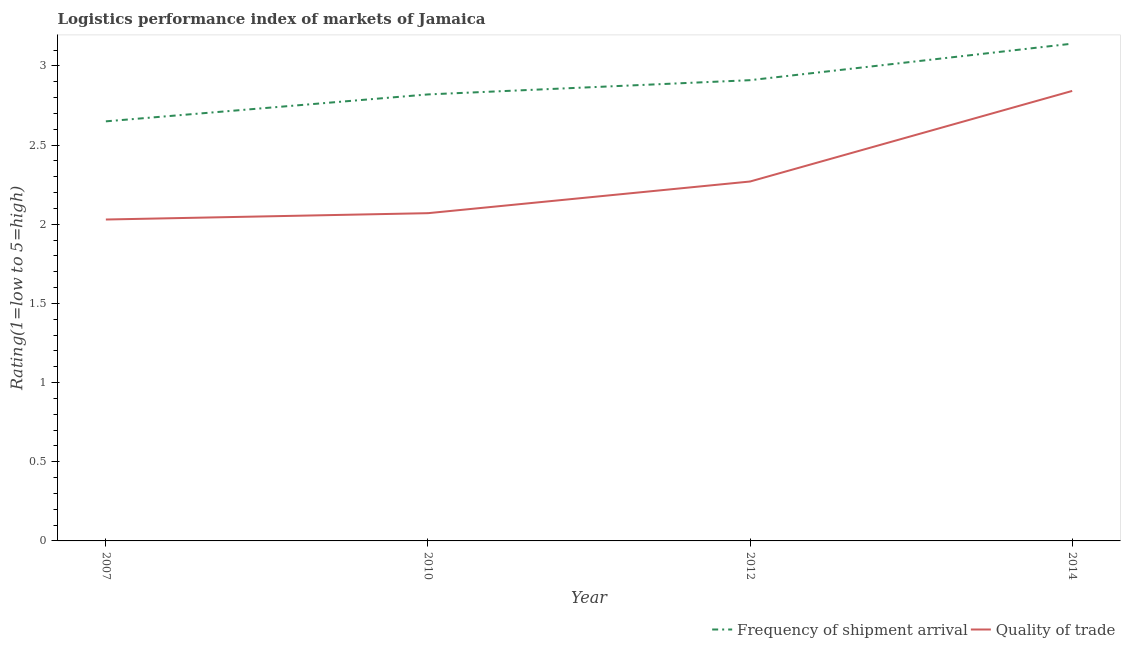What is the lpi of frequency of shipment arrival in 2014?
Make the answer very short. 3.14. Across all years, what is the maximum lpi of frequency of shipment arrival?
Your response must be concise. 3.14. Across all years, what is the minimum lpi of frequency of shipment arrival?
Your answer should be very brief. 2.65. In which year was the lpi quality of trade minimum?
Provide a succinct answer. 2007. What is the total lpi quality of trade in the graph?
Offer a very short reply. 9.21. What is the difference between the lpi of frequency of shipment arrival in 2010 and that in 2012?
Give a very brief answer. -0.09. What is the difference between the lpi quality of trade in 2007 and the lpi of frequency of shipment arrival in 2014?
Provide a short and direct response. -1.11. What is the average lpi of frequency of shipment arrival per year?
Offer a terse response. 2.88. In the year 2007, what is the difference between the lpi of frequency of shipment arrival and lpi quality of trade?
Offer a very short reply. 0.62. In how many years, is the lpi of frequency of shipment arrival greater than 0.30000000000000004?
Offer a very short reply. 4. What is the ratio of the lpi of frequency of shipment arrival in 2012 to that in 2014?
Provide a short and direct response. 0.93. What is the difference between the highest and the second highest lpi quality of trade?
Provide a succinct answer. 0.57. What is the difference between the highest and the lowest lpi quality of trade?
Give a very brief answer. 0.81. Is the sum of the lpi quality of trade in 2010 and 2012 greater than the maximum lpi of frequency of shipment arrival across all years?
Ensure brevity in your answer.  Yes. Does the lpi of frequency of shipment arrival monotonically increase over the years?
Give a very brief answer. Yes. Is the lpi quality of trade strictly greater than the lpi of frequency of shipment arrival over the years?
Your answer should be compact. No. Is the lpi of frequency of shipment arrival strictly less than the lpi quality of trade over the years?
Provide a succinct answer. No. How many years are there in the graph?
Keep it short and to the point. 4. What is the difference between two consecutive major ticks on the Y-axis?
Ensure brevity in your answer.  0.5. Does the graph contain any zero values?
Your answer should be compact. No. Does the graph contain grids?
Your answer should be very brief. No. What is the title of the graph?
Provide a succinct answer. Logistics performance index of markets of Jamaica. What is the label or title of the Y-axis?
Offer a very short reply. Rating(1=low to 5=high). What is the Rating(1=low to 5=high) in Frequency of shipment arrival in 2007?
Give a very brief answer. 2.65. What is the Rating(1=low to 5=high) of Quality of trade in 2007?
Ensure brevity in your answer.  2.03. What is the Rating(1=low to 5=high) of Frequency of shipment arrival in 2010?
Your response must be concise. 2.82. What is the Rating(1=low to 5=high) in Quality of trade in 2010?
Your answer should be compact. 2.07. What is the Rating(1=low to 5=high) of Frequency of shipment arrival in 2012?
Your answer should be very brief. 2.91. What is the Rating(1=low to 5=high) in Quality of trade in 2012?
Give a very brief answer. 2.27. What is the Rating(1=low to 5=high) in Frequency of shipment arrival in 2014?
Offer a terse response. 3.14. What is the Rating(1=low to 5=high) in Quality of trade in 2014?
Offer a very short reply. 2.84. Across all years, what is the maximum Rating(1=low to 5=high) of Frequency of shipment arrival?
Provide a short and direct response. 3.14. Across all years, what is the maximum Rating(1=low to 5=high) of Quality of trade?
Provide a succinct answer. 2.84. Across all years, what is the minimum Rating(1=low to 5=high) in Frequency of shipment arrival?
Offer a terse response. 2.65. Across all years, what is the minimum Rating(1=low to 5=high) of Quality of trade?
Provide a succinct answer. 2.03. What is the total Rating(1=low to 5=high) in Frequency of shipment arrival in the graph?
Ensure brevity in your answer.  11.52. What is the total Rating(1=low to 5=high) of Quality of trade in the graph?
Make the answer very short. 9.21. What is the difference between the Rating(1=low to 5=high) in Frequency of shipment arrival in 2007 and that in 2010?
Ensure brevity in your answer.  -0.17. What is the difference between the Rating(1=low to 5=high) in Quality of trade in 2007 and that in 2010?
Ensure brevity in your answer.  -0.04. What is the difference between the Rating(1=low to 5=high) in Frequency of shipment arrival in 2007 and that in 2012?
Ensure brevity in your answer.  -0.26. What is the difference between the Rating(1=low to 5=high) of Quality of trade in 2007 and that in 2012?
Keep it short and to the point. -0.24. What is the difference between the Rating(1=low to 5=high) of Frequency of shipment arrival in 2007 and that in 2014?
Your answer should be very brief. -0.49. What is the difference between the Rating(1=low to 5=high) in Quality of trade in 2007 and that in 2014?
Your answer should be very brief. -0.81. What is the difference between the Rating(1=low to 5=high) of Frequency of shipment arrival in 2010 and that in 2012?
Provide a short and direct response. -0.09. What is the difference between the Rating(1=low to 5=high) in Frequency of shipment arrival in 2010 and that in 2014?
Give a very brief answer. -0.32. What is the difference between the Rating(1=low to 5=high) in Quality of trade in 2010 and that in 2014?
Your response must be concise. -0.77. What is the difference between the Rating(1=low to 5=high) of Frequency of shipment arrival in 2012 and that in 2014?
Provide a succinct answer. -0.23. What is the difference between the Rating(1=low to 5=high) of Quality of trade in 2012 and that in 2014?
Offer a terse response. -0.57. What is the difference between the Rating(1=low to 5=high) in Frequency of shipment arrival in 2007 and the Rating(1=low to 5=high) in Quality of trade in 2010?
Ensure brevity in your answer.  0.58. What is the difference between the Rating(1=low to 5=high) of Frequency of shipment arrival in 2007 and the Rating(1=low to 5=high) of Quality of trade in 2012?
Offer a very short reply. 0.38. What is the difference between the Rating(1=low to 5=high) of Frequency of shipment arrival in 2007 and the Rating(1=low to 5=high) of Quality of trade in 2014?
Keep it short and to the point. -0.19. What is the difference between the Rating(1=low to 5=high) of Frequency of shipment arrival in 2010 and the Rating(1=low to 5=high) of Quality of trade in 2012?
Your response must be concise. 0.55. What is the difference between the Rating(1=low to 5=high) in Frequency of shipment arrival in 2010 and the Rating(1=low to 5=high) in Quality of trade in 2014?
Your answer should be compact. -0.02. What is the difference between the Rating(1=low to 5=high) in Frequency of shipment arrival in 2012 and the Rating(1=low to 5=high) in Quality of trade in 2014?
Your answer should be very brief. 0.07. What is the average Rating(1=low to 5=high) of Frequency of shipment arrival per year?
Offer a very short reply. 2.88. What is the average Rating(1=low to 5=high) in Quality of trade per year?
Offer a very short reply. 2.3. In the year 2007, what is the difference between the Rating(1=low to 5=high) in Frequency of shipment arrival and Rating(1=low to 5=high) in Quality of trade?
Give a very brief answer. 0.62. In the year 2010, what is the difference between the Rating(1=low to 5=high) in Frequency of shipment arrival and Rating(1=low to 5=high) in Quality of trade?
Your answer should be compact. 0.75. In the year 2012, what is the difference between the Rating(1=low to 5=high) in Frequency of shipment arrival and Rating(1=low to 5=high) in Quality of trade?
Ensure brevity in your answer.  0.64. In the year 2014, what is the difference between the Rating(1=low to 5=high) of Frequency of shipment arrival and Rating(1=low to 5=high) of Quality of trade?
Your answer should be compact. 0.3. What is the ratio of the Rating(1=low to 5=high) in Frequency of shipment arrival in 2007 to that in 2010?
Your response must be concise. 0.94. What is the ratio of the Rating(1=low to 5=high) of Quality of trade in 2007 to that in 2010?
Keep it short and to the point. 0.98. What is the ratio of the Rating(1=low to 5=high) of Frequency of shipment arrival in 2007 to that in 2012?
Your answer should be very brief. 0.91. What is the ratio of the Rating(1=low to 5=high) of Quality of trade in 2007 to that in 2012?
Your response must be concise. 0.89. What is the ratio of the Rating(1=low to 5=high) of Frequency of shipment arrival in 2007 to that in 2014?
Give a very brief answer. 0.84. What is the ratio of the Rating(1=low to 5=high) of Quality of trade in 2007 to that in 2014?
Give a very brief answer. 0.71. What is the ratio of the Rating(1=low to 5=high) in Frequency of shipment arrival in 2010 to that in 2012?
Your answer should be very brief. 0.97. What is the ratio of the Rating(1=low to 5=high) in Quality of trade in 2010 to that in 2012?
Offer a very short reply. 0.91. What is the ratio of the Rating(1=low to 5=high) of Frequency of shipment arrival in 2010 to that in 2014?
Your answer should be compact. 0.9. What is the ratio of the Rating(1=low to 5=high) in Quality of trade in 2010 to that in 2014?
Your answer should be very brief. 0.73. What is the ratio of the Rating(1=low to 5=high) in Frequency of shipment arrival in 2012 to that in 2014?
Your response must be concise. 0.93. What is the ratio of the Rating(1=low to 5=high) in Quality of trade in 2012 to that in 2014?
Your answer should be very brief. 0.8. What is the difference between the highest and the second highest Rating(1=low to 5=high) in Frequency of shipment arrival?
Provide a short and direct response. 0.23. What is the difference between the highest and the second highest Rating(1=low to 5=high) of Quality of trade?
Provide a short and direct response. 0.57. What is the difference between the highest and the lowest Rating(1=low to 5=high) in Frequency of shipment arrival?
Give a very brief answer. 0.49. What is the difference between the highest and the lowest Rating(1=low to 5=high) in Quality of trade?
Keep it short and to the point. 0.81. 